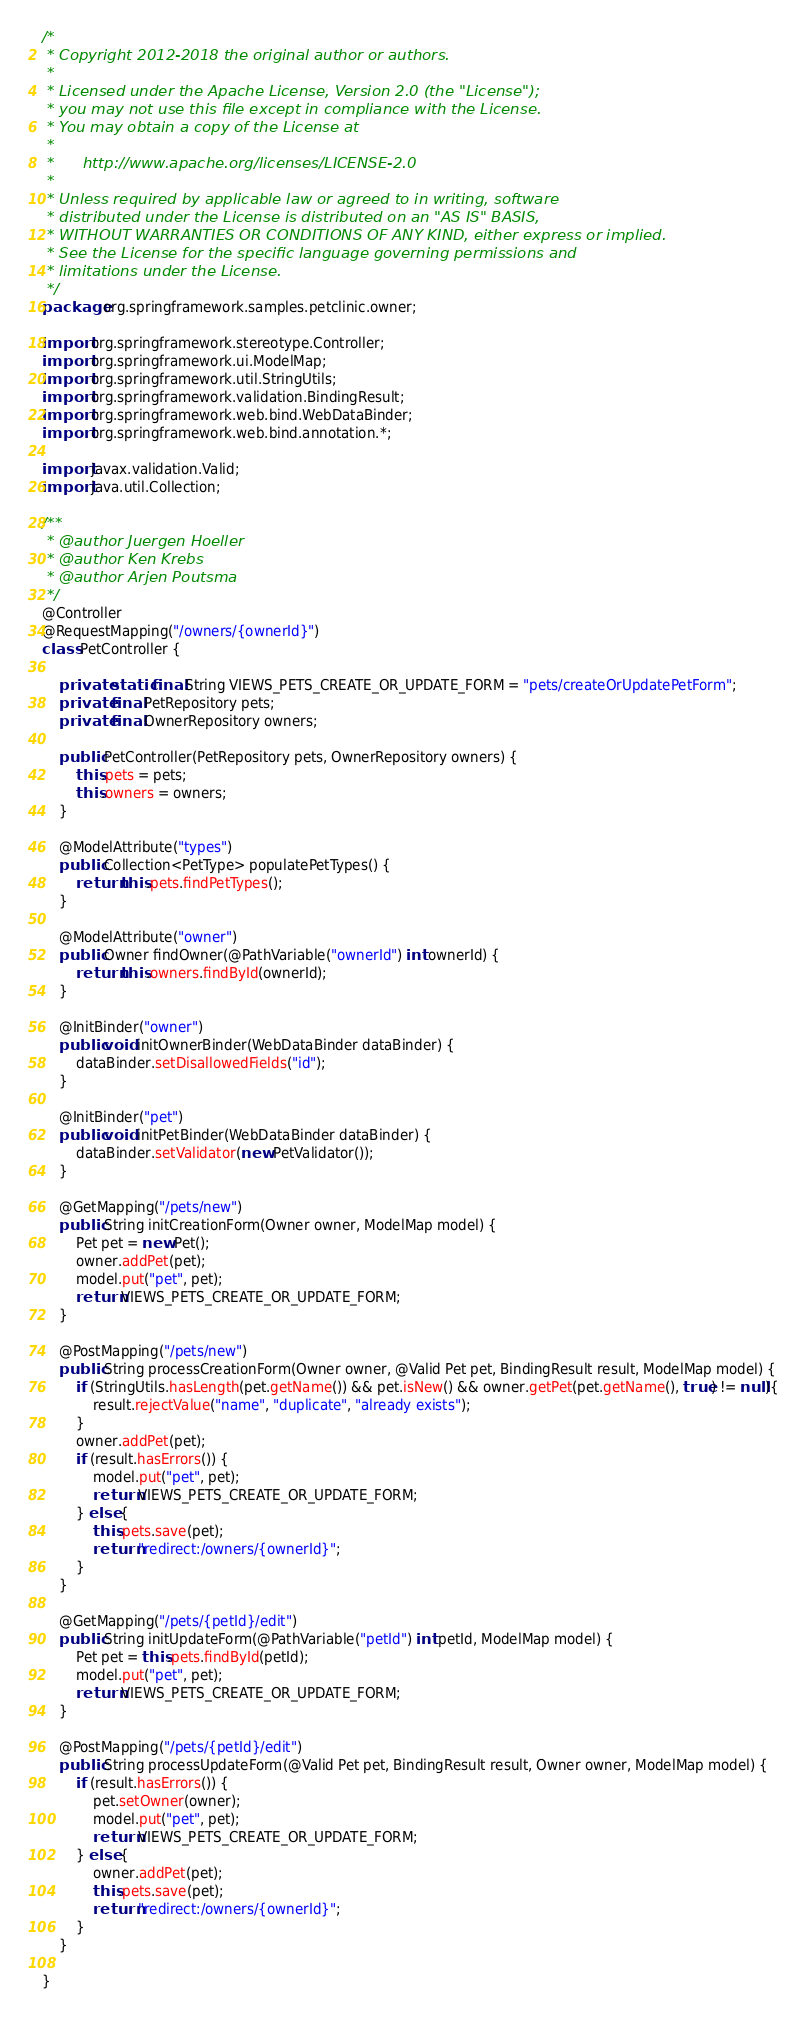<code> <loc_0><loc_0><loc_500><loc_500><_Java_>/*
 * Copyright 2012-2018 the original author or authors.
 *
 * Licensed under the Apache License, Version 2.0 (the "License");
 * you may not use this file except in compliance with the License.
 * You may obtain a copy of the License at
 *
 *      http://www.apache.org/licenses/LICENSE-2.0
 *
 * Unless required by applicable law or agreed to in writing, software
 * distributed under the License is distributed on an "AS IS" BASIS,
 * WITHOUT WARRANTIES OR CONDITIONS OF ANY KIND, either express or implied.
 * See the License for the specific language governing permissions and
 * limitations under the License.
 */
package org.springframework.samples.petclinic.owner;

import org.springframework.stereotype.Controller;
import org.springframework.ui.ModelMap;
import org.springframework.util.StringUtils;
import org.springframework.validation.BindingResult;
import org.springframework.web.bind.WebDataBinder;
import org.springframework.web.bind.annotation.*;

import javax.validation.Valid;
import java.util.Collection;

/**
 * @author Juergen Hoeller
 * @author Ken Krebs
 * @author Arjen Poutsma
 */
@Controller
@RequestMapping("/owners/{ownerId}")
class PetController {

    private static final String VIEWS_PETS_CREATE_OR_UPDATE_FORM = "pets/createOrUpdatePetForm";
    private final PetRepository pets;
    private final OwnerRepository owners;

    public PetController(PetRepository pets, OwnerRepository owners) {
        this.pets = pets;
        this.owners = owners;
    }

    @ModelAttribute("types")
    public Collection<PetType> populatePetTypes() {
        return this.pets.findPetTypes();
    }

    @ModelAttribute("owner")
    public Owner findOwner(@PathVariable("ownerId") int ownerId) {
        return this.owners.findById(ownerId);
    }

    @InitBinder("owner")
    public void initOwnerBinder(WebDataBinder dataBinder) {
        dataBinder.setDisallowedFields("id");
    }

    @InitBinder("pet")
    public void initPetBinder(WebDataBinder dataBinder) {
        dataBinder.setValidator(new PetValidator());
    }

    @GetMapping("/pets/new")
    public String initCreationForm(Owner owner, ModelMap model) {
        Pet pet = new Pet();
        owner.addPet(pet);
        model.put("pet", pet);
        return VIEWS_PETS_CREATE_OR_UPDATE_FORM;
    }

    @PostMapping("/pets/new")
    public String processCreationForm(Owner owner, @Valid Pet pet, BindingResult result, ModelMap model) {
        if (StringUtils.hasLength(pet.getName()) && pet.isNew() && owner.getPet(pet.getName(), true) != null){
            result.rejectValue("name", "duplicate", "already exists");
        }
        owner.addPet(pet);
        if (result.hasErrors()) {
            model.put("pet", pet);
            return VIEWS_PETS_CREATE_OR_UPDATE_FORM;
        } else {
            this.pets.save(pet);
            return "redirect:/owners/{ownerId}";
        }
    }

    @GetMapping("/pets/{petId}/edit")
    public String initUpdateForm(@PathVariable("petId") int petId, ModelMap model) {
        Pet pet = this.pets.findById(petId);
        model.put("pet", pet);
        return VIEWS_PETS_CREATE_OR_UPDATE_FORM;
    }

    @PostMapping("/pets/{petId}/edit")
    public String processUpdateForm(@Valid Pet pet, BindingResult result, Owner owner, ModelMap model) {
        if (result.hasErrors()) {
            pet.setOwner(owner);
            model.put("pet", pet);
            return VIEWS_PETS_CREATE_OR_UPDATE_FORM;
        } else {
            owner.addPet(pet);
            this.pets.save(pet);
            return "redirect:/owners/{ownerId}";
        }
    }

}
</code> 